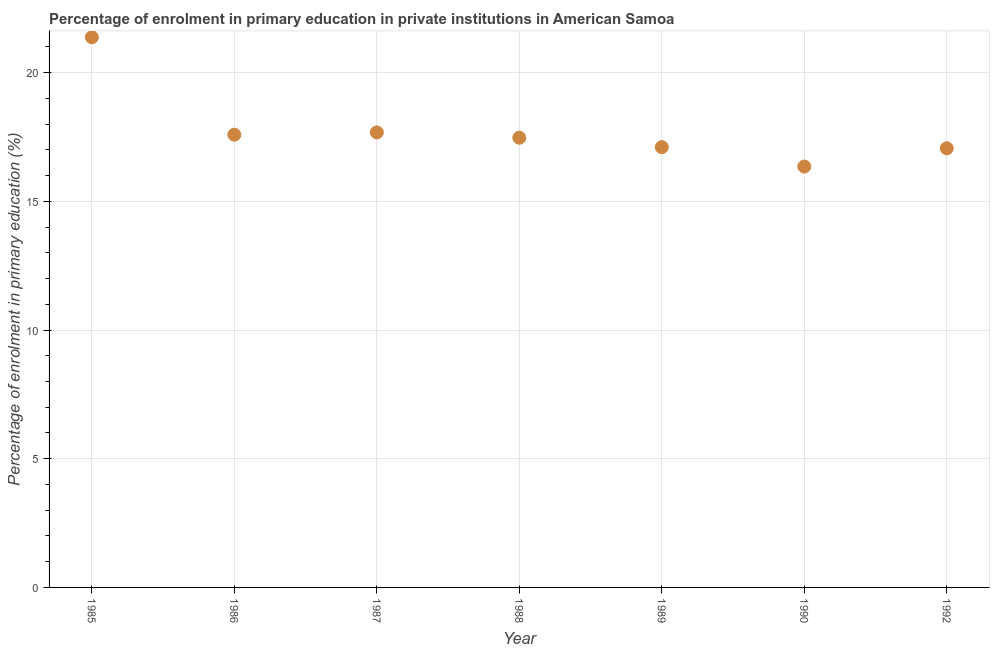What is the enrolment percentage in primary education in 1988?
Provide a succinct answer. 17.47. Across all years, what is the maximum enrolment percentage in primary education?
Your response must be concise. 21.37. Across all years, what is the minimum enrolment percentage in primary education?
Offer a very short reply. 16.35. In which year was the enrolment percentage in primary education maximum?
Ensure brevity in your answer.  1985. In which year was the enrolment percentage in primary education minimum?
Your answer should be compact. 1990. What is the sum of the enrolment percentage in primary education?
Keep it short and to the point. 124.63. What is the difference between the enrolment percentage in primary education in 1988 and 1990?
Provide a short and direct response. 1.12. What is the average enrolment percentage in primary education per year?
Make the answer very short. 17.8. What is the median enrolment percentage in primary education?
Keep it short and to the point. 17.47. What is the ratio of the enrolment percentage in primary education in 1987 to that in 1989?
Provide a short and direct response. 1.03. Is the difference between the enrolment percentage in primary education in 1987 and 1989 greater than the difference between any two years?
Make the answer very short. No. What is the difference between the highest and the second highest enrolment percentage in primary education?
Your answer should be very brief. 3.69. Is the sum of the enrolment percentage in primary education in 1988 and 1992 greater than the maximum enrolment percentage in primary education across all years?
Your answer should be compact. Yes. What is the difference between the highest and the lowest enrolment percentage in primary education?
Your answer should be compact. 5.02. How many dotlines are there?
Keep it short and to the point. 1. Does the graph contain any zero values?
Your answer should be compact. No. Does the graph contain grids?
Offer a very short reply. Yes. What is the title of the graph?
Your answer should be very brief. Percentage of enrolment in primary education in private institutions in American Samoa. What is the label or title of the Y-axis?
Make the answer very short. Percentage of enrolment in primary education (%). What is the Percentage of enrolment in primary education (%) in 1985?
Offer a very short reply. 21.37. What is the Percentage of enrolment in primary education (%) in 1986?
Make the answer very short. 17.59. What is the Percentage of enrolment in primary education (%) in 1987?
Give a very brief answer. 17.68. What is the Percentage of enrolment in primary education (%) in 1988?
Your answer should be compact. 17.47. What is the Percentage of enrolment in primary education (%) in 1989?
Your answer should be compact. 17.1. What is the Percentage of enrolment in primary education (%) in 1990?
Offer a terse response. 16.35. What is the Percentage of enrolment in primary education (%) in 1992?
Ensure brevity in your answer.  17.06. What is the difference between the Percentage of enrolment in primary education (%) in 1985 and 1986?
Offer a terse response. 3.78. What is the difference between the Percentage of enrolment in primary education (%) in 1985 and 1987?
Your response must be concise. 3.69. What is the difference between the Percentage of enrolment in primary education (%) in 1985 and 1988?
Your answer should be compact. 3.9. What is the difference between the Percentage of enrolment in primary education (%) in 1985 and 1989?
Ensure brevity in your answer.  4.27. What is the difference between the Percentage of enrolment in primary education (%) in 1985 and 1990?
Offer a terse response. 5.02. What is the difference between the Percentage of enrolment in primary education (%) in 1985 and 1992?
Your answer should be compact. 4.31. What is the difference between the Percentage of enrolment in primary education (%) in 1986 and 1987?
Give a very brief answer. -0.09. What is the difference between the Percentage of enrolment in primary education (%) in 1986 and 1988?
Ensure brevity in your answer.  0.12. What is the difference between the Percentage of enrolment in primary education (%) in 1986 and 1989?
Your answer should be very brief. 0.48. What is the difference between the Percentage of enrolment in primary education (%) in 1986 and 1990?
Give a very brief answer. 1.24. What is the difference between the Percentage of enrolment in primary education (%) in 1986 and 1992?
Give a very brief answer. 0.53. What is the difference between the Percentage of enrolment in primary education (%) in 1987 and 1988?
Give a very brief answer. 0.21. What is the difference between the Percentage of enrolment in primary education (%) in 1987 and 1989?
Your response must be concise. 0.57. What is the difference between the Percentage of enrolment in primary education (%) in 1987 and 1990?
Ensure brevity in your answer.  1.33. What is the difference between the Percentage of enrolment in primary education (%) in 1987 and 1992?
Ensure brevity in your answer.  0.62. What is the difference between the Percentage of enrolment in primary education (%) in 1988 and 1989?
Your response must be concise. 0.37. What is the difference between the Percentage of enrolment in primary education (%) in 1988 and 1990?
Give a very brief answer. 1.12. What is the difference between the Percentage of enrolment in primary education (%) in 1988 and 1992?
Give a very brief answer. 0.41. What is the difference between the Percentage of enrolment in primary education (%) in 1989 and 1990?
Offer a very short reply. 0.75. What is the difference between the Percentage of enrolment in primary education (%) in 1989 and 1992?
Your answer should be compact. 0.04. What is the difference between the Percentage of enrolment in primary education (%) in 1990 and 1992?
Provide a succinct answer. -0.71. What is the ratio of the Percentage of enrolment in primary education (%) in 1985 to that in 1986?
Provide a short and direct response. 1.22. What is the ratio of the Percentage of enrolment in primary education (%) in 1985 to that in 1987?
Ensure brevity in your answer.  1.21. What is the ratio of the Percentage of enrolment in primary education (%) in 1985 to that in 1988?
Keep it short and to the point. 1.22. What is the ratio of the Percentage of enrolment in primary education (%) in 1985 to that in 1990?
Keep it short and to the point. 1.31. What is the ratio of the Percentage of enrolment in primary education (%) in 1985 to that in 1992?
Ensure brevity in your answer.  1.25. What is the ratio of the Percentage of enrolment in primary education (%) in 1986 to that in 1988?
Keep it short and to the point. 1.01. What is the ratio of the Percentage of enrolment in primary education (%) in 1986 to that in 1989?
Provide a short and direct response. 1.03. What is the ratio of the Percentage of enrolment in primary education (%) in 1986 to that in 1990?
Your response must be concise. 1.08. What is the ratio of the Percentage of enrolment in primary education (%) in 1986 to that in 1992?
Provide a succinct answer. 1.03. What is the ratio of the Percentage of enrolment in primary education (%) in 1987 to that in 1989?
Keep it short and to the point. 1.03. What is the ratio of the Percentage of enrolment in primary education (%) in 1987 to that in 1990?
Your answer should be very brief. 1.08. What is the ratio of the Percentage of enrolment in primary education (%) in 1987 to that in 1992?
Your answer should be compact. 1.04. What is the ratio of the Percentage of enrolment in primary education (%) in 1988 to that in 1990?
Provide a succinct answer. 1.07. What is the ratio of the Percentage of enrolment in primary education (%) in 1989 to that in 1990?
Provide a short and direct response. 1.05. What is the ratio of the Percentage of enrolment in primary education (%) in 1990 to that in 1992?
Offer a very short reply. 0.96. 